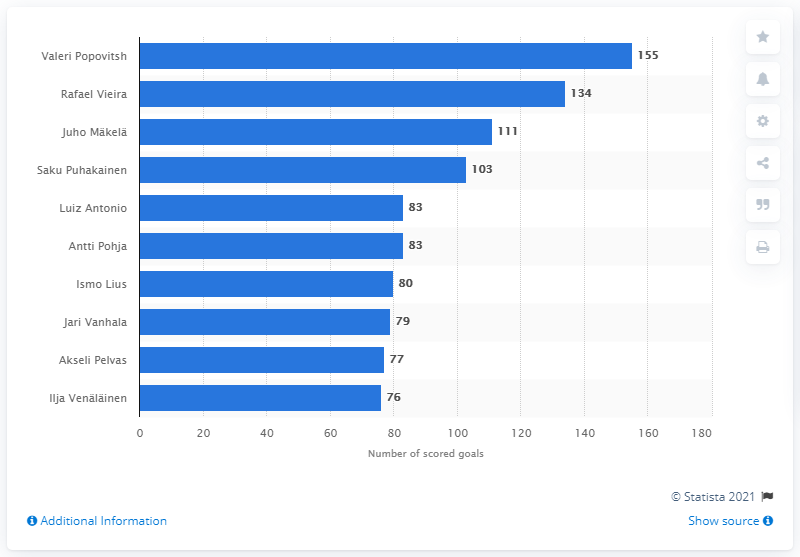Highlight a few significant elements in this photo. As of 2020, Valeri Popovitsh had scored a total of 155 goals. Rafael Vieira is the second highest scorer in the Finnish Football League. Valeri Popovitsh led the scoreboard of the Finnish Football League in 2020. 